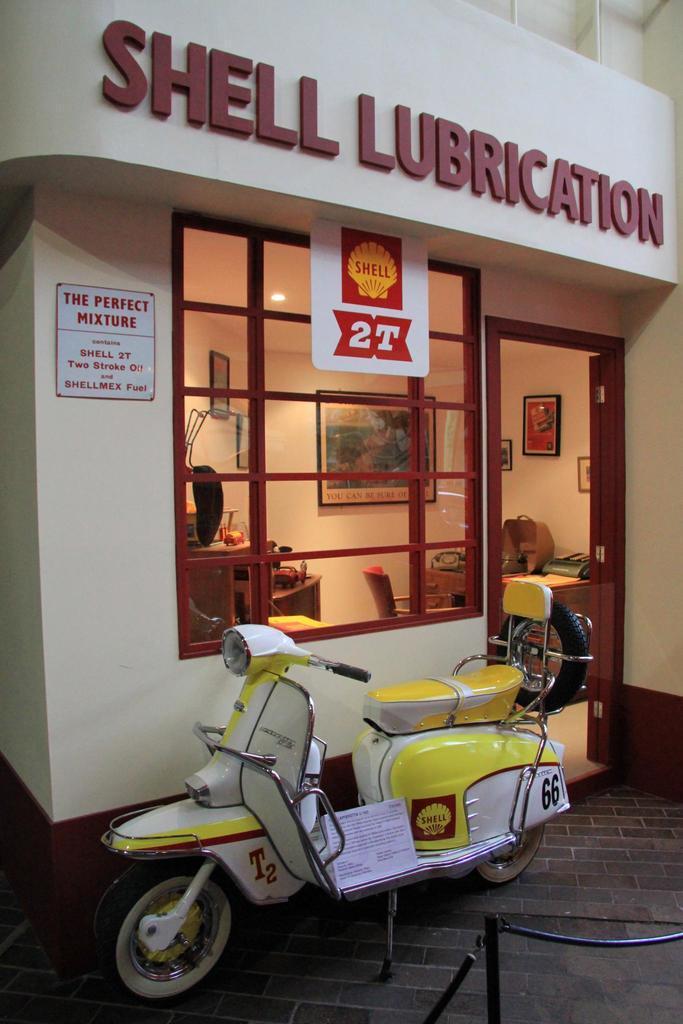How would you summarize this image in a sentence or two? In the foreground a scooter is visible of yellow and white in color. And a building of white in color visible. and a window and door is there in which wall paintings, photo frames is there. In the middle a table is there on which a system is kept and other materials are kept and chair is there. This image is taken outside the building. 